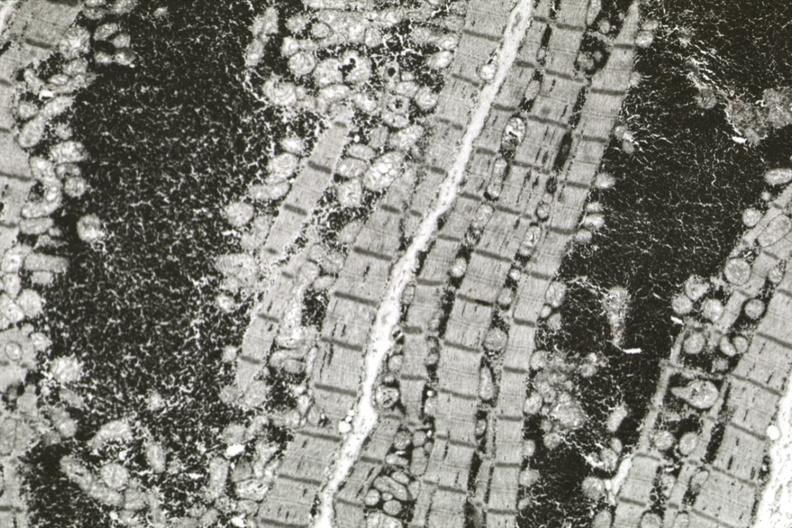s cardiovascular present?
Answer the question using a single word or phrase. Yes 